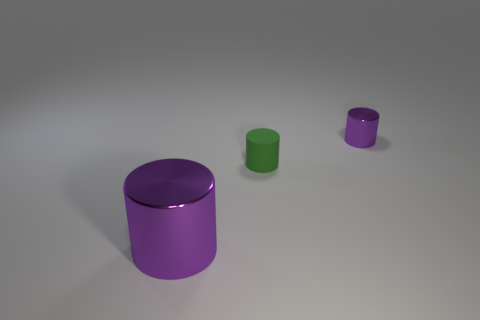Subtract all small cylinders. How many cylinders are left? 1 Subtract all green cylinders. How many cylinders are left? 2 Add 1 gray cylinders. How many objects exist? 4 Subtract 0 gray blocks. How many objects are left? 3 Subtract all cyan cylinders. Subtract all gray blocks. How many cylinders are left? 3 Subtract all red spheres. How many yellow cylinders are left? 0 Subtract all yellow blocks. Subtract all small objects. How many objects are left? 1 Add 1 small green cylinders. How many small green cylinders are left? 2 Add 2 cylinders. How many cylinders exist? 5 